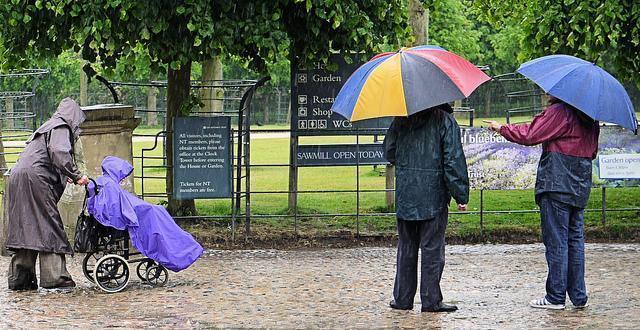What is the purple outfit the woman is wearing called?
Choose the right answer from the provided options to respond to the question.
Options: Smock, blanket, poncho, robe. Poncho. 